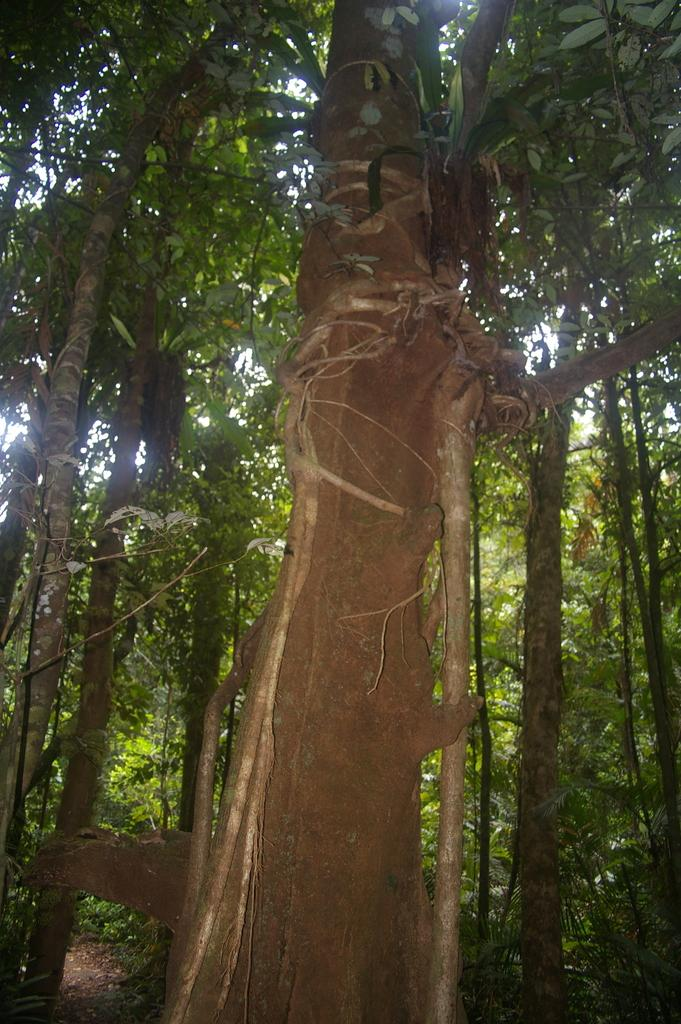What is the main subject of the image? The main subject of the image is a tree trunk. Can you describe the background of the image? In the background of the image, there are trees with branches and leaves. What type of drug is being used to measure the distance between the tree trunk and the trees in the background? There is no drug or measurement mentioned in the image, and the distance between the tree trunk and the trees in the background cannot be determined from the image. 